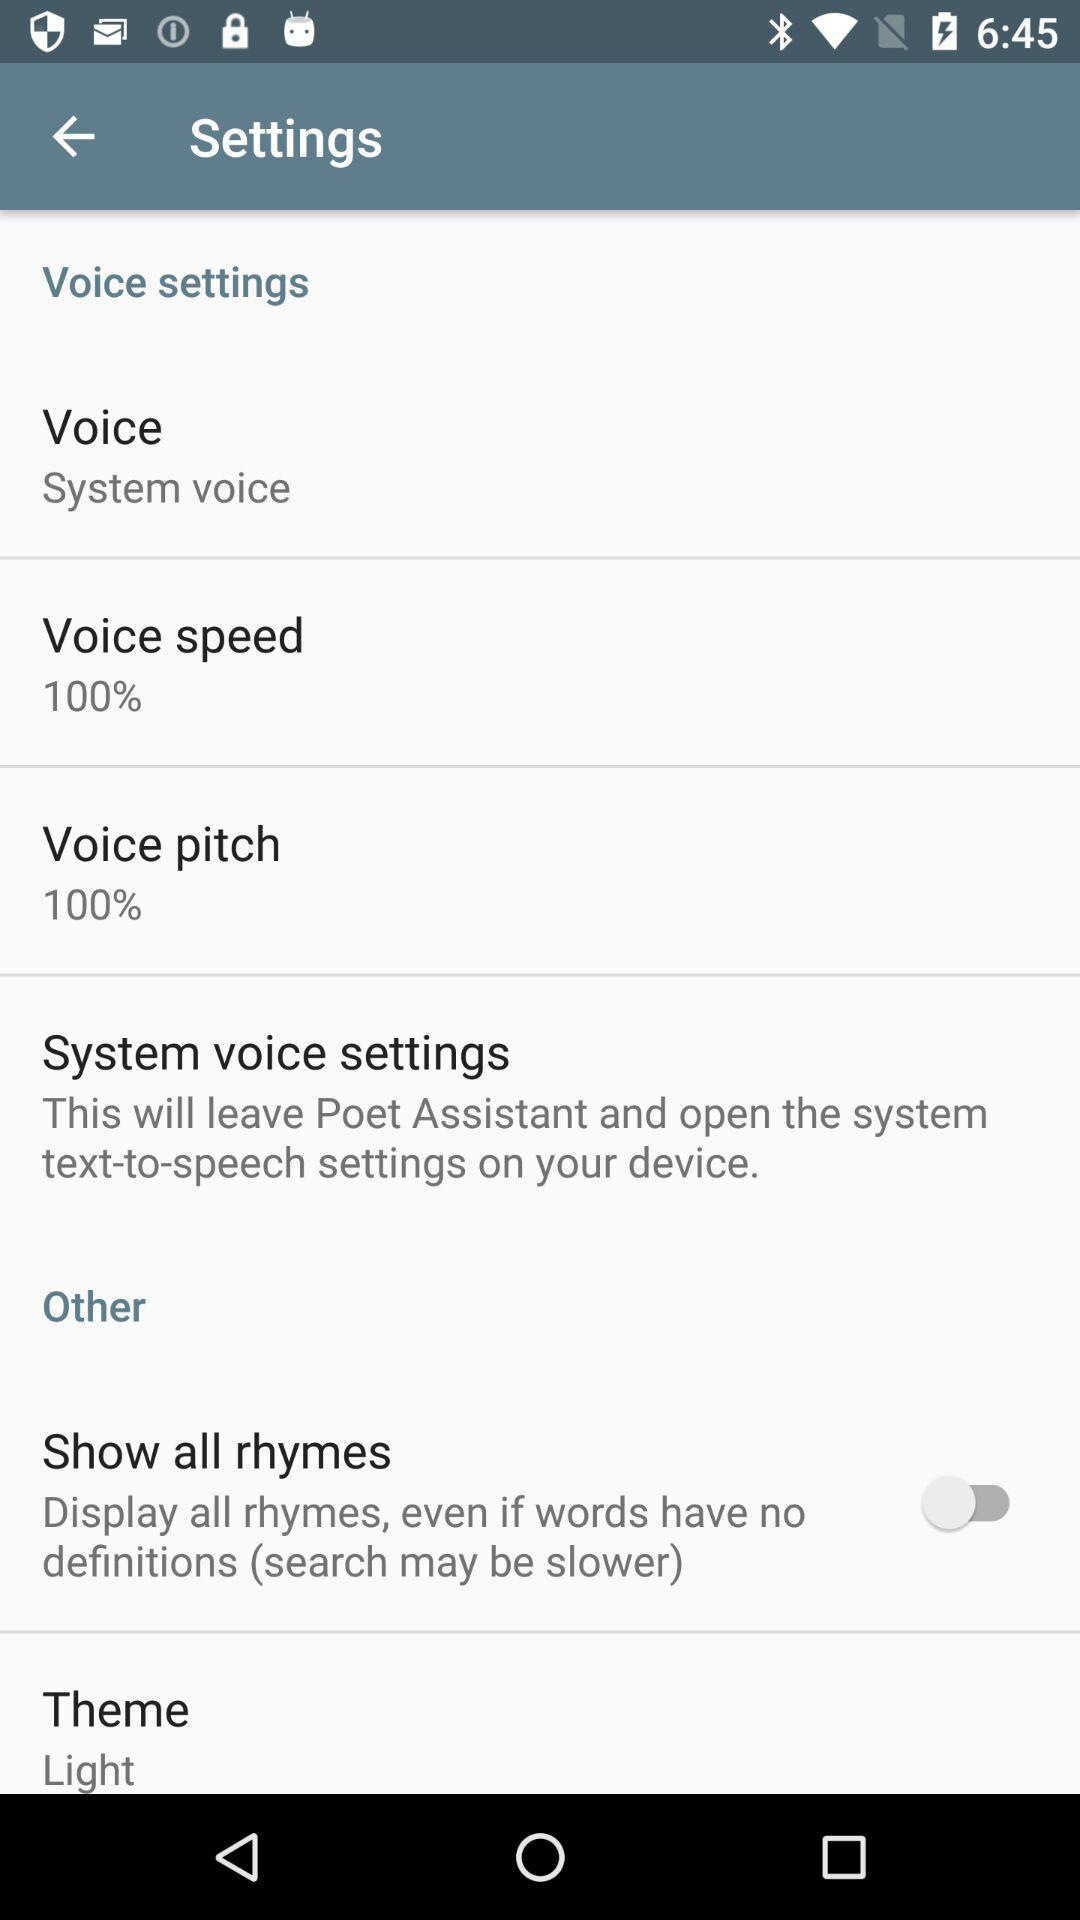What is the status of "Show all rhymes"? The status is "off". 